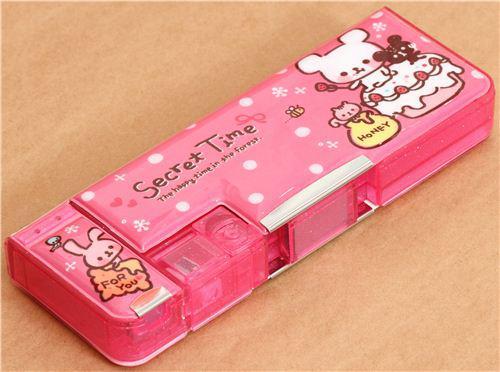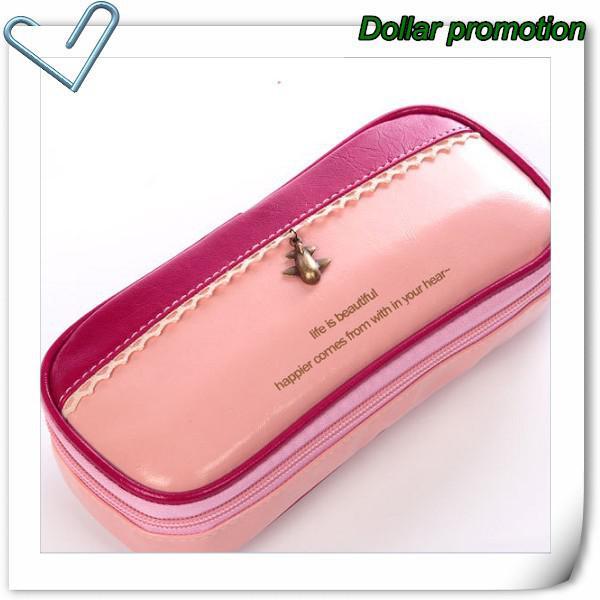The first image is the image on the left, the second image is the image on the right. Analyze the images presented: Is the assertion "An image shows a grouping of at least three pencil cases of the same size." valid? Answer yes or no. No. The first image is the image on the left, the second image is the image on the right. Analyze the images presented: Is the assertion "One photo contains three or more pencil cases." valid? Answer yes or no. No. 